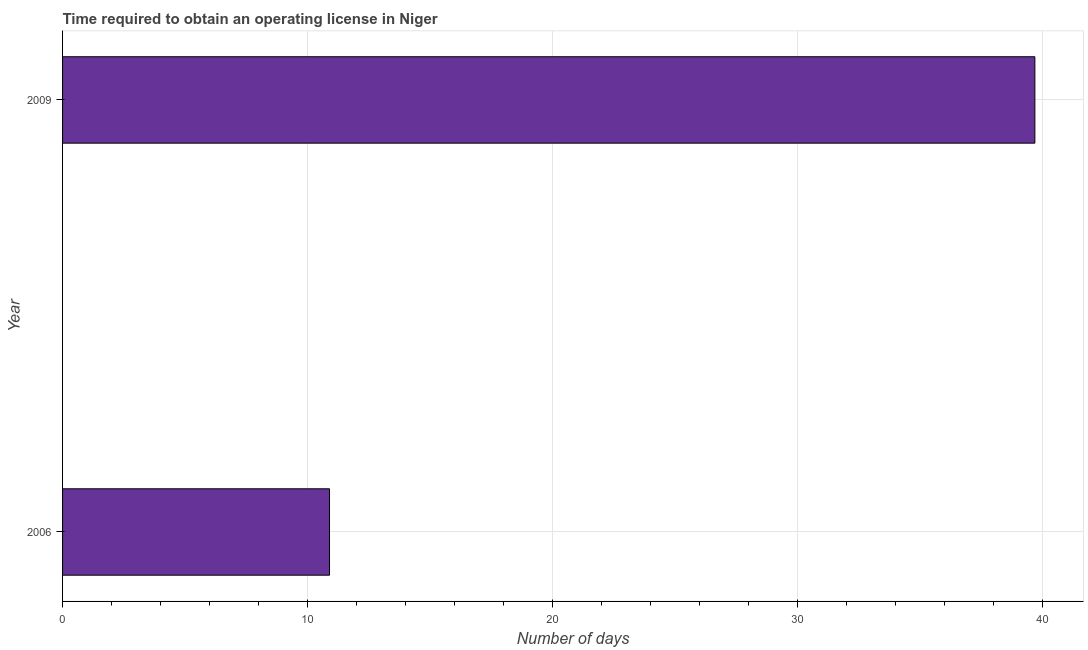Does the graph contain any zero values?
Ensure brevity in your answer.  No. Does the graph contain grids?
Ensure brevity in your answer.  Yes. What is the title of the graph?
Offer a terse response. Time required to obtain an operating license in Niger. What is the label or title of the X-axis?
Make the answer very short. Number of days. What is the number of days to obtain operating license in 2006?
Keep it short and to the point. 10.9. Across all years, what is the maximum number of days to obtain operating license?
Ensure brevity in your answer.  39.7. Across all years, what is the minimum number of days to obtain operating license?
Keep it short and to the point. 10.9. What is the sum of the number of days to obtain operating license?
Ensure brevity in your answer.  50.6. What is the difference between the number of days to obtain operating license in 2006 and 2009?
Your response must be concise. -28.8. What is the average number of days to obtain operating license per year?
Your response must be concise. 25.3. What is the median number of days to obtain operating license?
Give a very brief answer. 25.3. What is the ratio of the number of days to obtain operating license in 2006 to that in 2009?
Provide a succinct answer. 0.28. Is the number of days to obtain operating license in 2006 less than that in 2009?
Provide a short and direct response. Yes. In how many years, is the number of days to obtain operating license greater than the average number of days to obtain operating license taken over all years?
Give a very brief answer. 1. Are the values on the major ticks of X-axis written in scientific E-notation?
Keep it short and to the point. No. What is the Number of days of 2009?
Your answer should be compact. 39.7. What is the difference between the Number of days in 2006 and 2009?
Ensure brevity in your answer.  -28.8. What is the ratio of the Number of days in 2006 to that in 2009?
Offer a very short reply. 0.28. 